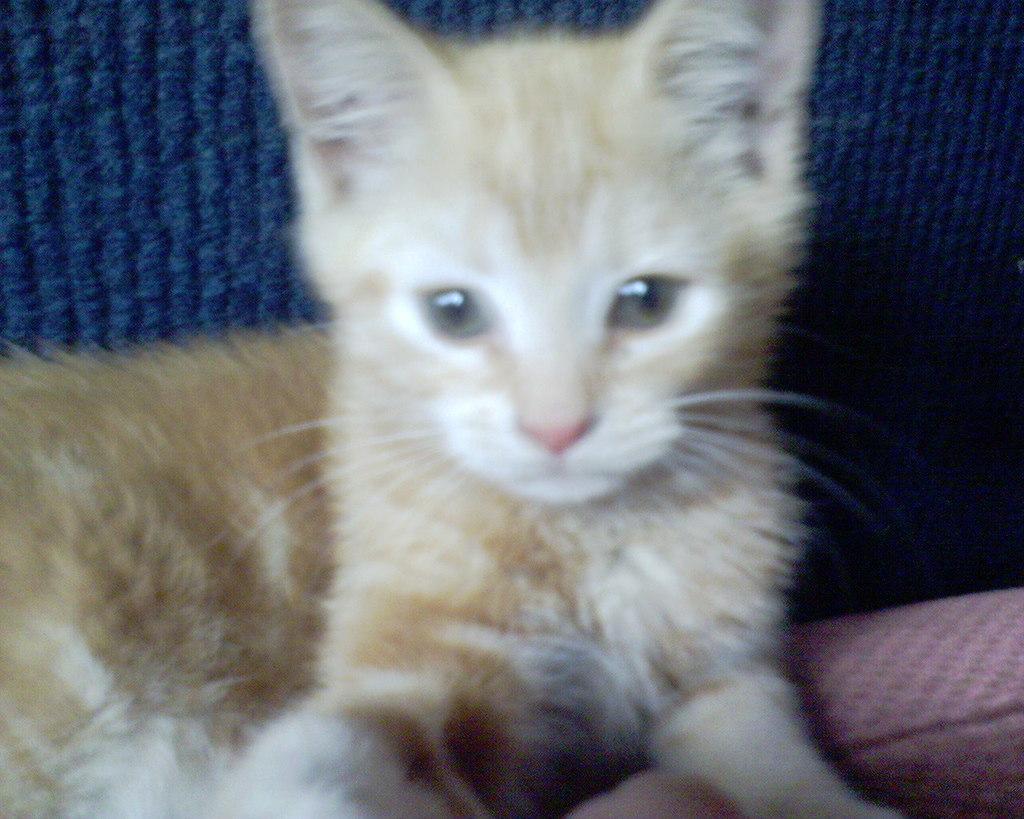Can you describe this image briefly? In this picture I can see the kitten in the middle. 